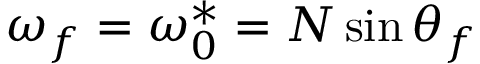Convert formula to latex. <formula><loc_0><loc_0><loc_500><loc_500>\omega _ { f } = \omega _ { 0 } ^ { * } = N \sin \theta _ { f }</formula> 